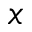<formula> <loc_0><loc_0><loc_500><loc_500>x</formula> 